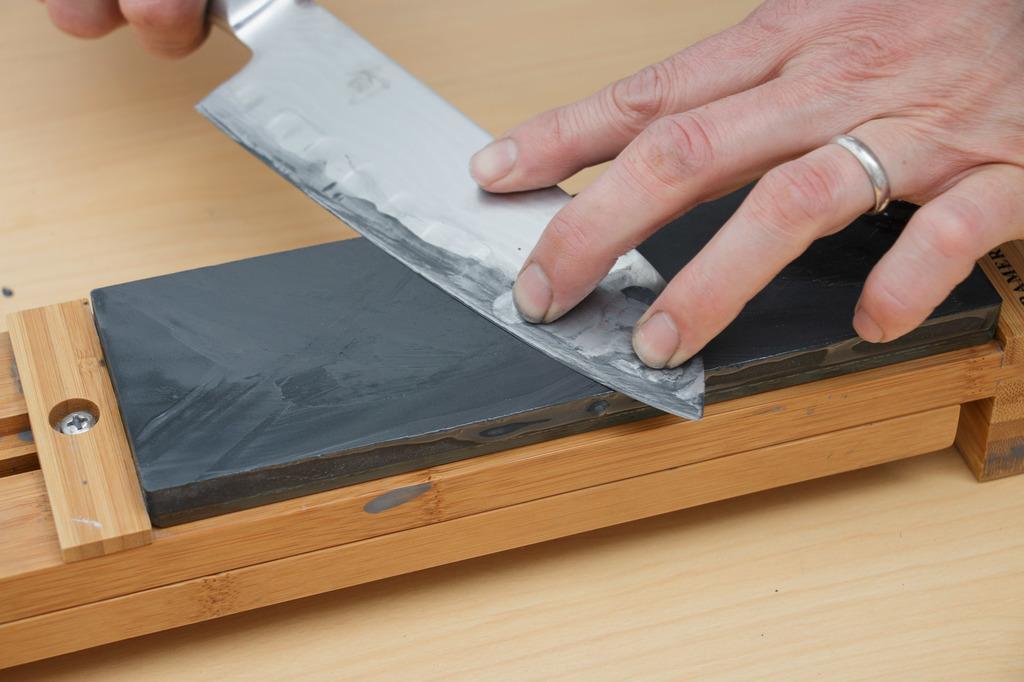Could you give a brief overview of what you see in this image? In this image, we can see a hand holding a knife which is on the knife sharpener. There is an another hand in the top right of the image. 